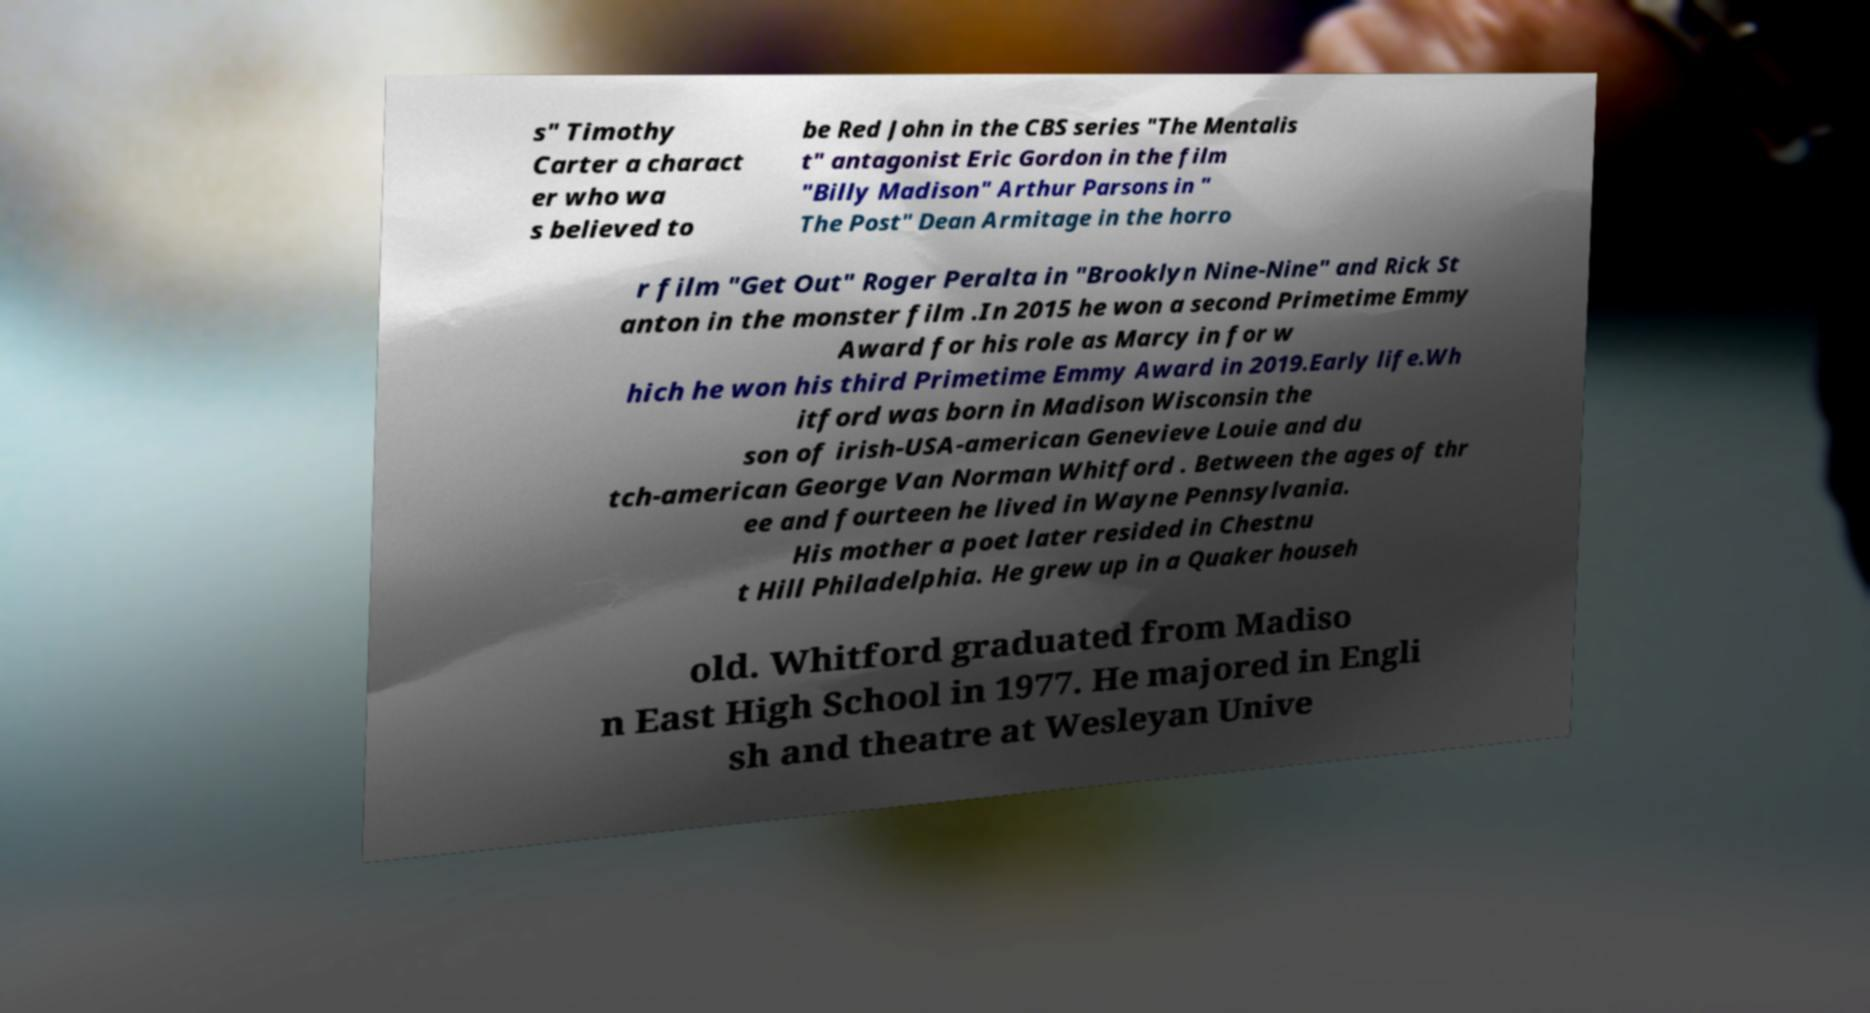For documentation purposes, I need the text within this image transcribed. Could you provide that? s" Timothy Carter a charact er who wa s believed to be Red John in the CBS series "The Mentalis t" antagonist Eric Gordon in the film "Billy Madison" Arthur Parsons in " The Post" Dean Armitage in the horro r film "Get Out" Roger Peralta in "Brooklyn Nine-Nine" and Rick St anton in the monster film .In 2015 he won a second Primetime Emmy Award for his role as Marcy in for w hich he won his third Primetime Emmy Award in 2019.Early life.Wh itford was born in Madison Wisconsin the son of irish-USA-american Genevieve Louie and du tch-american George Van Norman Whitford . Between the ages of thr ee and fourteen he lived in Wayne Pennsylvania. His mother a poet later resided in Chestnu t Hill Philadelphia. He grew up in a Quaker househ old. Whitford graduated from Madiso n East High School in 1977. He majored in Engli sh and theatre at Wesleyan Unive 